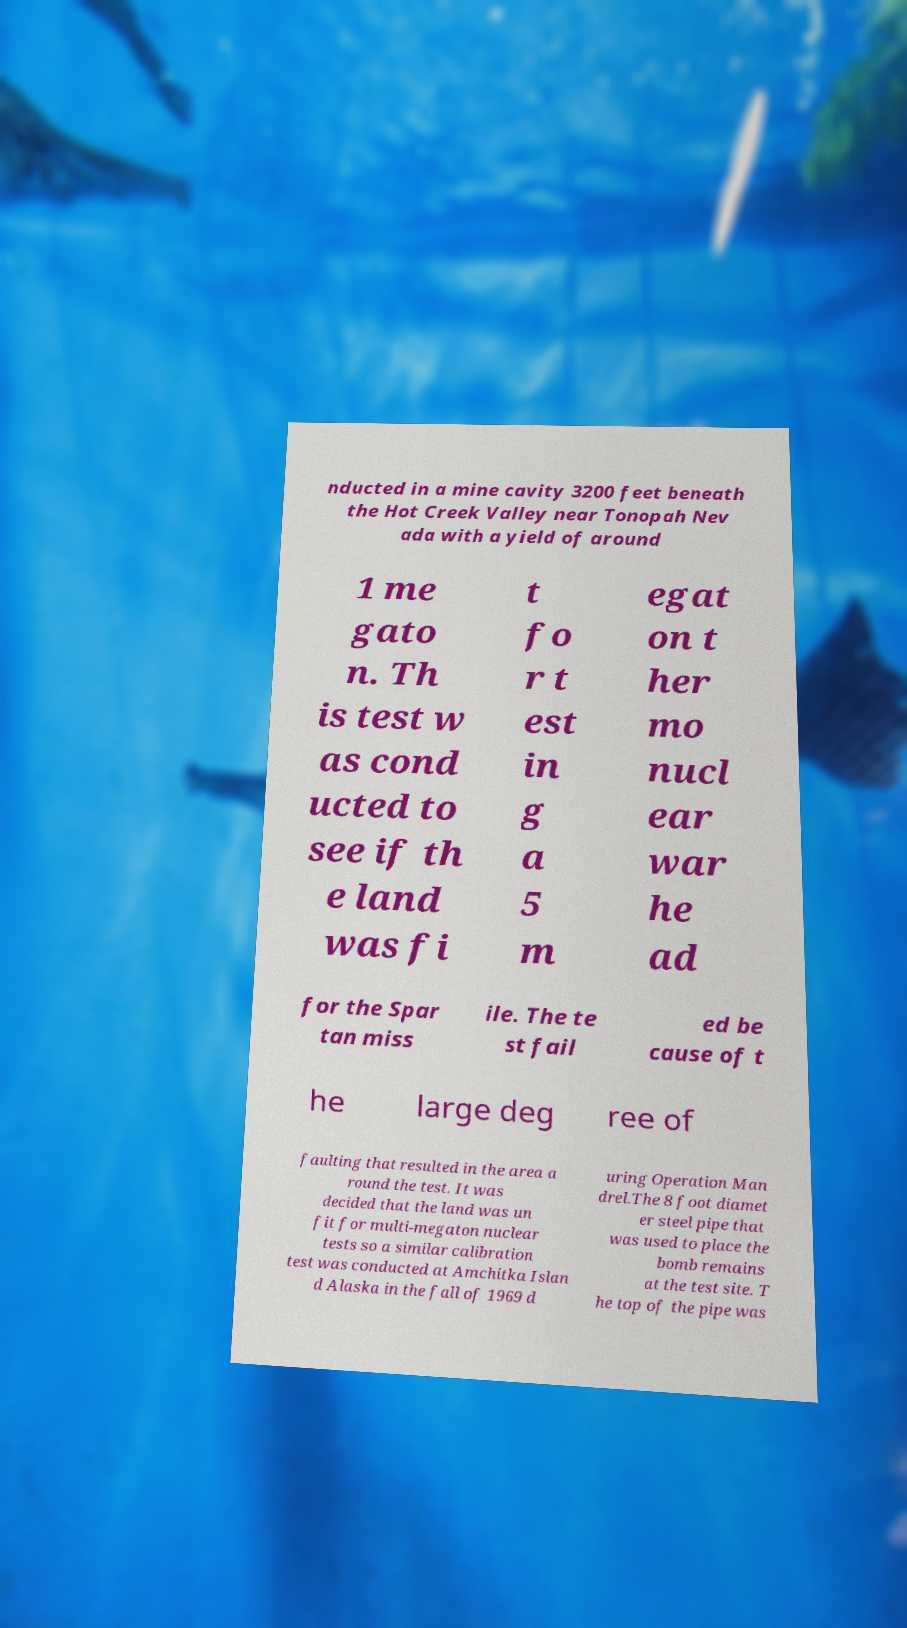There's text embedded in this image that I need extracted. Can you transcribe it verbatim? nducted in a mine cavity 3200 feet beneath the Hot Creek Valley near Tonopah Nev ada with a yield of around 1 me gato n. Th is test w as cond ucted to see if th e land was fi t fo r t est in g a 5 m egat on t her mo nucl ear war he ad for the Spar tan miss ile. The te st fail ed be cause of t he large deg ree of faulting that resulted in the area a round the test. It was decided that the land was un fit for multi-megaton nuclear tests so a similar calibration test was conducted at Amchitka Islan d Alaska in the fall of 1969 d uring Operation Man drel.The 8 foot diamet er steel pipe that was used to place the bomb remains at the test site. T he top of the pipe was 